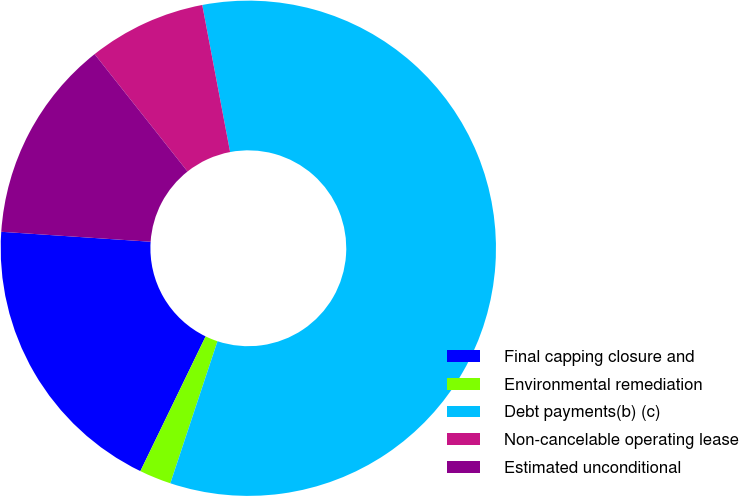Convert chart. <chart><loc_0><loc_0><loc_500><loc_500><pie_chart><fcel>Final capping closure and<fcel>Environmental remediation<fcel>Debt payments(b) (c)<fcel>Non-cancelable operating lease<fcel>Estimated unconditional<nl><fcel>18.88%<fcel>2.08%<fcel>58.08%<fcel>7.68%<fcel>13.28%<nl></chart> 